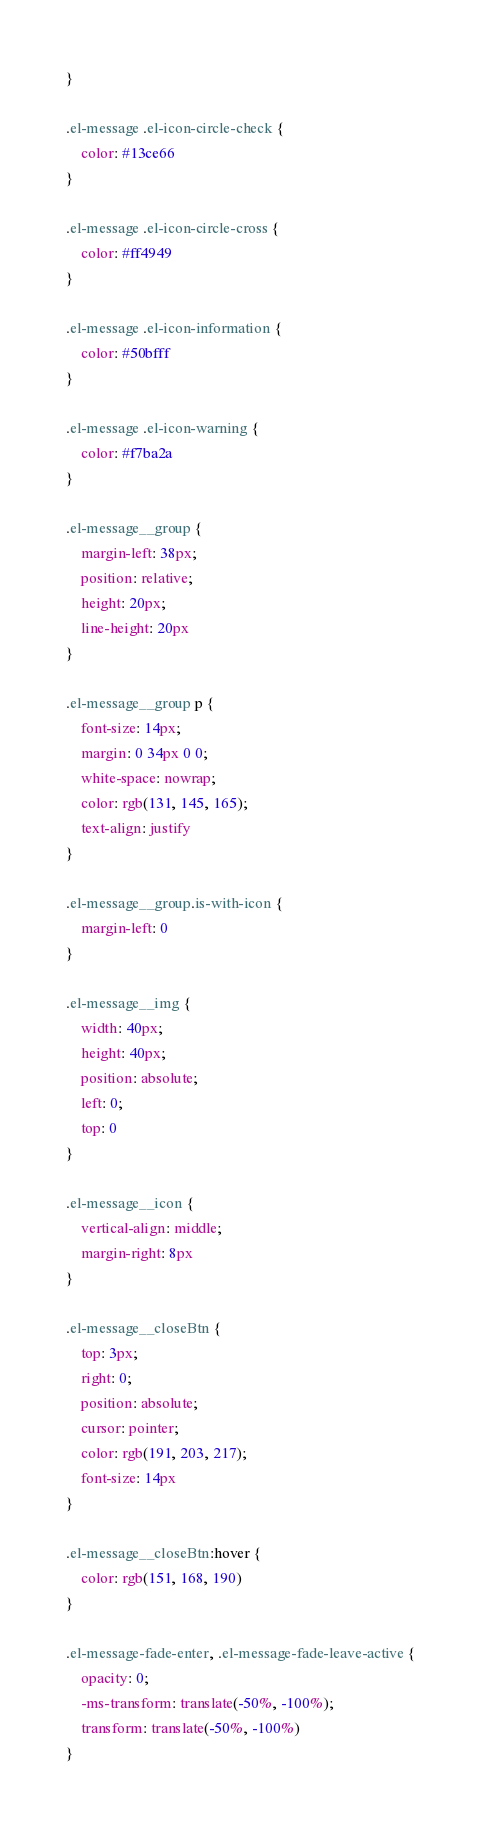Convert code to text. <code><loc_0><loc_0><loc_500><loc_500><_CSS_>}

.el-message .el-icon-circle-check {
    color: #13ce66
}

.el-message .el-icon-circle-cross {
    color: #ff4949
}

.el-message .el-icon-information {
    color: #50bfff
}

.el-message .el-icon-warning {
    color: #f7ba2a
}

.el-message__group {
    margin-left: 38px;
    position: relative;
    height: 20px;
    line-height: 20px
}

.el-message__group p {
    font-size: 14px;
    margin: 0 34px 0 0;
    white-space: nowrap;
    color: rgb(131, 145, 165);
    text-align: justify
}

.el-message__group.is-with-icon {
    margin-left: 0
}

.el-message__img {
    width: 40px;
    height: 40px;
    position: absolute;
    left: 0;
    top: 0
}

.el-message__icon {
    vertical-align: middle;
    margin-right: 8px
}

.el-message__closeBtn {
    top: 3px;
    right: 0;
    position: absolute;
    cursor: pointer;
    color: rgb(191, 203, 217);
    font-size: 14px
}

.el-message__closeBtn:hover {
    color: rgb(151, 168, 190)
}

.el-message-fade-enter, .el-message-fade-leave-active {
    opacity: 0;
    -ms-transform: translate(-50%, -100%);
    transform: translate(-50%, -100%)
}</code> 